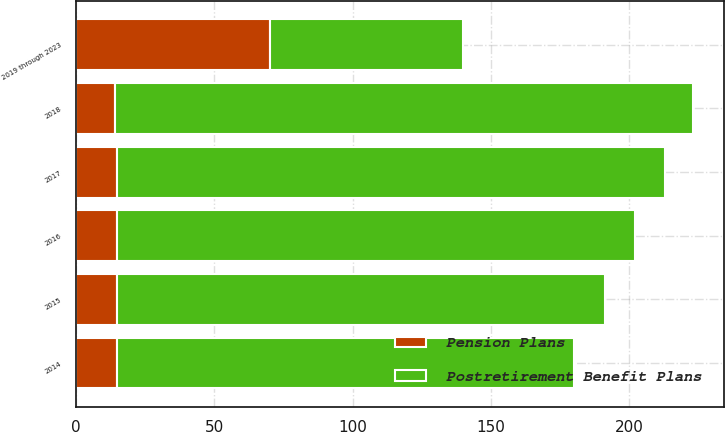Convert chart. <chart><loc_0><loc_0><loc_500><loc_500><stacked_bar_chart><ecel><fcel>2014<fcel>2015<fcel>2016<fcel>2017<fcel>2018<fcel>2019 through 2023<nl><fcel>Postretirement Benefit Plans<fcel>165<fcel>176<fcel>187<fcel>198<fcel>209<fcel>70<nl><fcel>Pension Plans<fcel>15<fcel>15<fcel>15<fcel>15<fcel>14<fcel>70<nl></chart> 